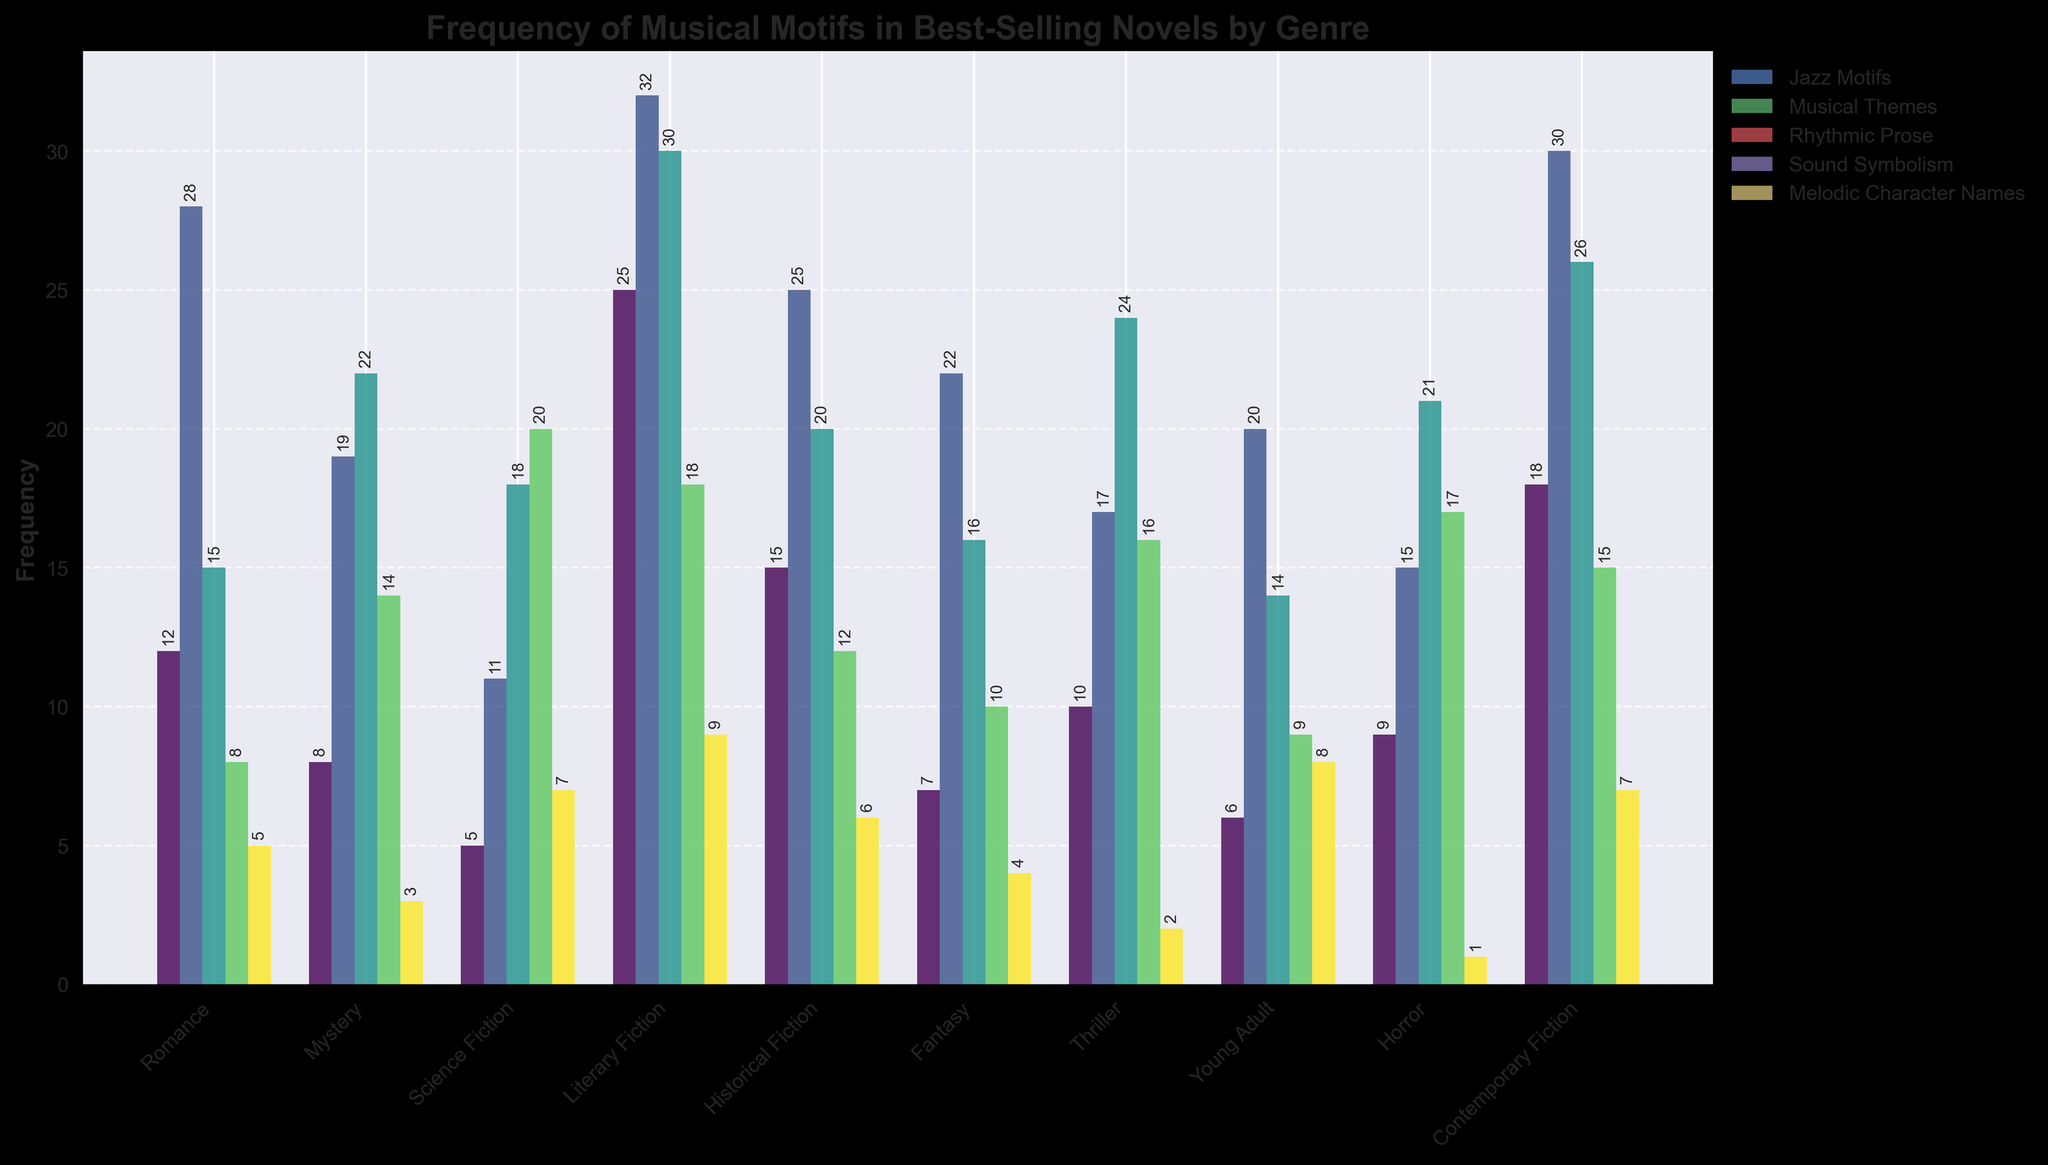What's the genre with the highest frequency of Jazz Motifs? By looking at the bar chart for Jazz Motifs, the highest bar belongs to Literary Fiction.
Answer: Literary Fiction Which genre has the fewest occurrences of Melodic Character Names? Among the bars for Melodic Character Names, the smallest bar belongs to Horror.
Answer: Horror Compare the sum of Jazz Motifs and Rhythmic Prose frequencies for Romance and Mystery genres. Which genre has a higher sum? Romance has 12 Jazz Motifs + 15 Rhythmic Prose = 27. Mystery has 8 Jazz Motifs + 22 Rhythmic Prose = 30. Therefore, Mystery has a higher sum.
Answer: Mystery How many genres have a frequency of Sound Symbolism greater than 15? By examining each bar for Sound Symbolism, the genres with frequencies greater than 15 are Science Fiction (20), Thriller (16), Horror (17), and Literary Fiction (18). That makes 4 genres in total.
Answer: 4 What is the total frequency of Musical Themes across all genres? Summing up the frequencies for each genre: 28 (Romance) + 19 (Mystery) + 11 (Science Fiction) + 32 (Literary Fiction) + 25 (Historical Fiction) + 22 (Fantasy) + 17 (Thriller) + 20 (Young Adult) + 15 (Horror) + 30 (Contemporary Fiction) = 219.
Answer: 219 Which two genres have equal frequencies for any musical motif category? Looking at the chart, both Historical Fiction and Mystery have an equal frequency of Musical Themes, which is 25.
Answer: Historical Fiction and Mystery Considering the sum of Sound Symbolism and Melodic Character Names frequencies, which genre ranks second highest? Literary Fiction has 18 + 9 = 27, Science Fiction has 20 + 7 = 27, and Contemporary Fiction has 15 + 7 = 22. Thus, Literary Fiction and Science Fiction tie for the second-highest sum.
Answer: Literary Fiction and Science Fiction Is there any genre where the frequency of Rhythmic Prose is higher than Sound Symbolism, but lower than Musical Themes? In Mystery, Rhythmic Prose is 22, Sound Symbolism is 14, and Musical Themes is 19. Rhythmic Prose is higher than Sound Symbolism and lower than Musical Themes.
Answer: Mystery Which musical motif has the greatest frequency in Horror, and how does it compare to the same motif in Thriller? Rhythmic Prose has the highest frequency in Horror (21) compared to Thriller (24) for the same motif. Thriller has a higher frequency for Rhythmic Prose than Horror.
Answer: Rhythmic Prose; Thriller higher 